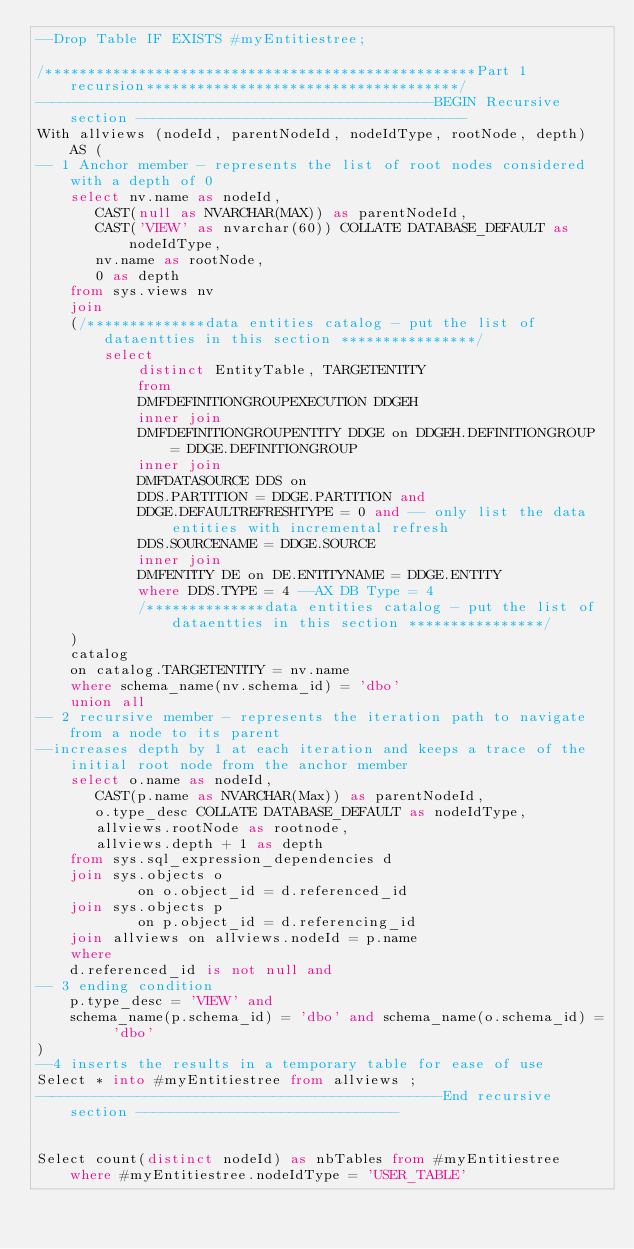<code> <loc_0><loc_0><loc_500><loc_500><_SQL_>--Drop Table IF EXISTS #myEntitiestree;

/***************************************************Part 1 recursion*************************************/ 
-----------------------------------------------BEGIN Recursive section ---------------------------------------
With allviews (nodeId, parentNodeId, nodeIdType, rootNode, depth) AS (
-- 1 Anchor member - represents the list of root nodes considered with a depth of 0	
	select nv.name as nodeId,
       CAST(null as NVARCHAR(MAX)) as parentNodeId,
       CAST('VIEW' as nvarchar(60)) COLLATE DATABASE_DEFAULT as nodeIdType,
	   nv.name as rootNode,
	   0 as depth
	from sys.views nv
	join 
	(/**************data entities catalog - put the list of dataentties in this section ****************/
		select 
			distinct EntityTable, TARGETENTITY
			from 
			DMFDEFINITIONGROUPEXECUTION DDGEH
			inner join
			DMFDEFINITIONGROUPENTITY DDGE on DDGEH.DEFINITIONGROUP = DDGE.DEFINITIONGROUP
			inner join 
			DMFDATASOURCE DDS on 
			DDS.PARTITION = DDGE.PARTITION and 
			DDGE.DEFAULTREFRESHTYPE = 0 and -- only list the data entities with incremental refresh
			DDS.SOURCENAME = DDGE.SOURCE 
			inner join 
			DMFENTITY DE on DE.ENTITYNAME = DDGE.ENTITY
			where DDS.TYPE = 4 --AX DB Type = 4 
			/**************data entities catalog - put the list of dataentties in this section ****************/
	) 
	catalog
	on catalog.TARGETENTITY = nv.name
	where schema_name(nv.schema_id) = 'dbo' 	
	union all
-- 2 recursive member - represents the iteration path to navigate from a node to its parent
--increases depth by 1 at each iteration and keeps a trace of the initial root node from the anchor member 
	select o.name as nodeId,
       CAST(p.name as NVARCHAR(Max)) as parentNodeId,
       o.type_desc COLLATE DATABASE_DEFAULT as nodeIdType,
	   allviews.rootNode as rootnode,
	   allviews.depth + 1 as depth
	from sys.sql_expression_dependencies d
	join sys.objects o
			on o.object_id = d.referenced_id
	join sys.objects p
			on p.object_id = d.referencing_id
	join allviews on allviews.nodeId = p.name
	where 
	d.referenced_id is not null and 
-- 3 ending condition
	p.type_desc = 'VIEW' and
	schema_name(p.schema_id) = 'dbo' and schema_name(o.schema_id) = 'dbo'
)
--4 inserts the results in a temporary table for ease of use
Select * into #myEntitiestree from allviews ;
------------------------------------------------End recursive section -------------------------------


Select count(distinct nodeId) as nbTables from #myEntitiestree where #myEntitiestree.nodeIdType = 'USER_TABLE'</code> 